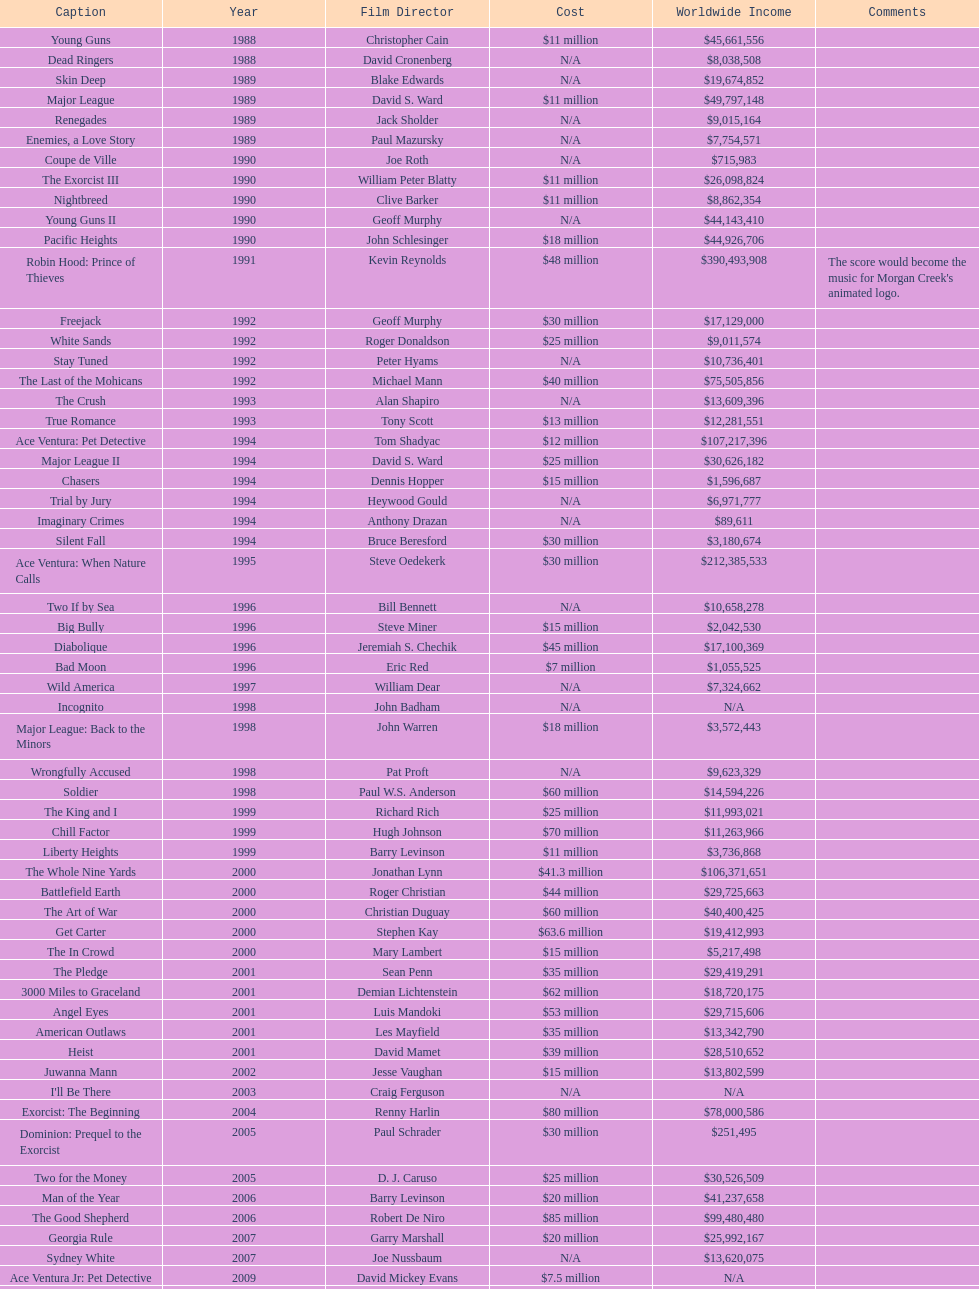How many films did morgan creek make in 2006? 2. 